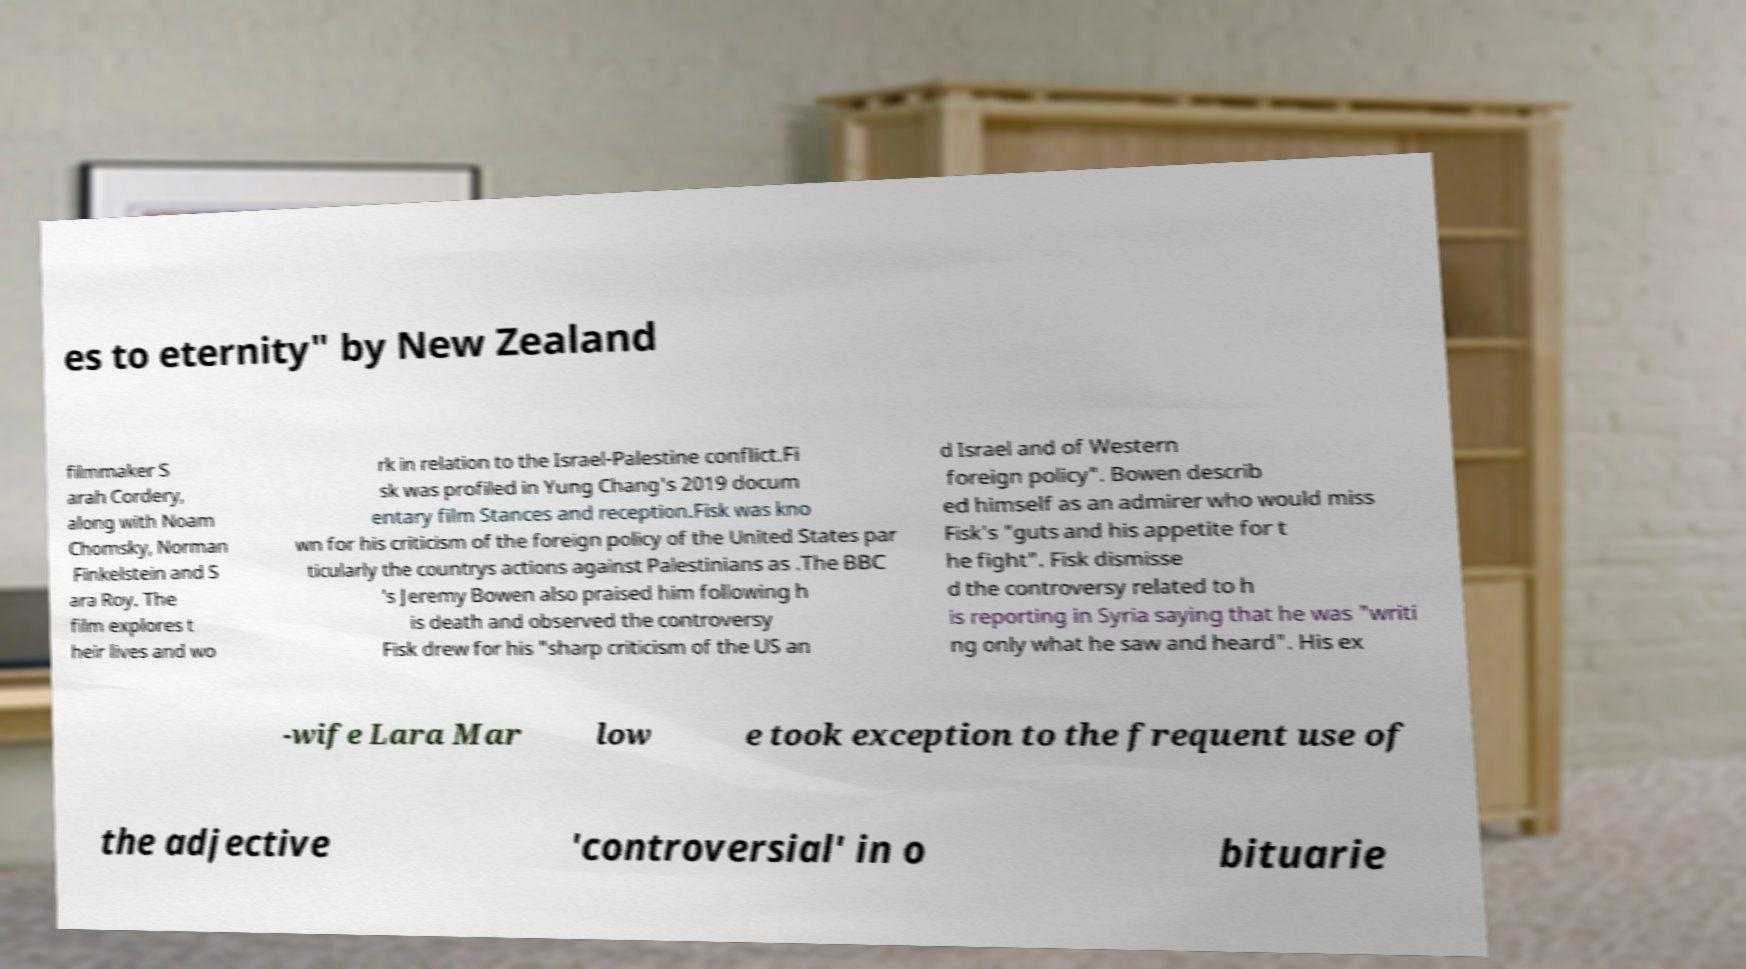I need the written content from this picture converted into text. Can you do that? es to eternity" by New Zealand filmmaker S arah Cordery, along with Noam Chomsky, Norman Finkelstein and S ara Roy. The film explores t heir lives and wo rk in relation to the Israel-Palestine conflict.Fi sk was profiled in Yung Chang's 2019 docum entary film Stances and reception.Fisk was kno wn for his criticism of the foreign policy of the United States par ticularly the countrys actions against Palestinians as .The BBC 's Jeremy Bowen also praised him following h is death and observed the controversy Fisk drew for his "sharp criticism of the US an d Israel and of Western foreign policy". Bowen describ ed himself as an admirer who would miss Fisk's "guts and his appetite for t he fight". Fisk dismisse d the controversy related to h is reporting in Syria saying that he was "writi ng only what he saw and heard". His ex -wife Lara Mar low e took exception to the frequent use of the adjective 'controversial' in o bituarie 